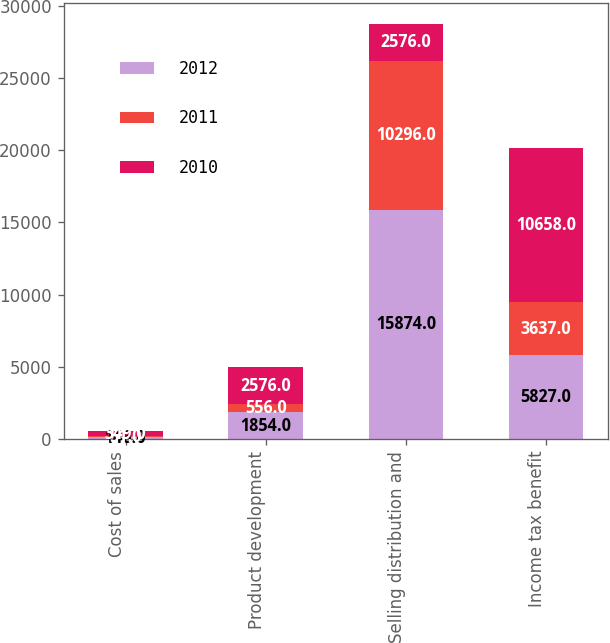<chart> <loc_0><loc_0><loc_500><loc_500><stacked_bar_chart><ecel><fcel>Cost of sales<fcel>Product development<fcel>Selling distribution and<fcel>Income tax benefit<nl><fcel>2012<fcel>146<fcel>1854<fcel>15874<fcel>5827<nl><fcel>2011<fcel>51<fcel>556<fcel>10296<fcel>3637<nl><fcel>2010<fcel>349<fcel>2576<fcel>2576<fcel>10658<nl></chart> 